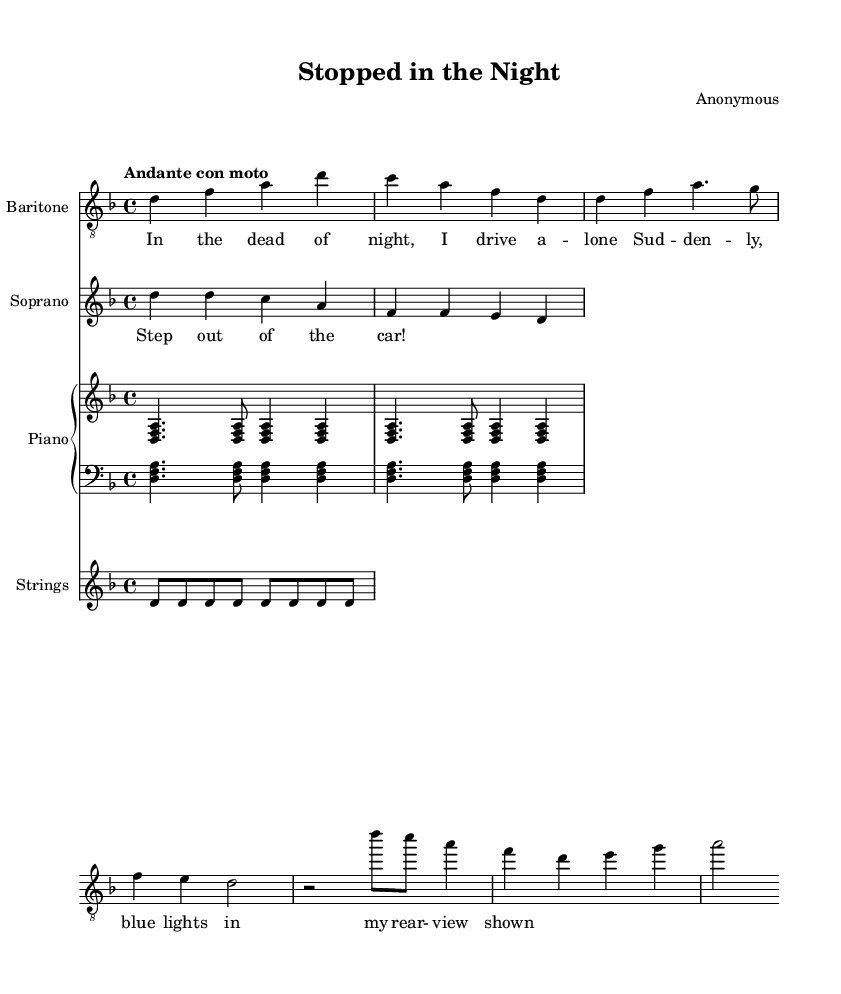What is the key signature of this music? The key signature in the piece is D minor, which has one flat (B flat). This is determined by identifying the key signature symbol at the beginning of the staff.
Answer: D minor What is the time signature of the music? The time signature is displayed at the beginning of the score and indicates the meter of the piece. In this case, it shows 4/4, meaning there are four beats per measure, and a quarter note gets one beat.
Answer: 4/4 What is the tempo marking for this operatic piece? The tempo marking is indicated above the staff. Here, it is labeled "Andante con moto," which specifies a moderate tempo with some movement.
Answer: Andante con moto Who is the vocalist for the taxi driver part? The vocal part for the taxi driver is labeled as "Baritone" in the score. This is shown in the staff heading at the beginning of the corresponding voice part.
Answer: Baritone How many measures does the taxi driver section contain in this excerpt? Counting the measures in the taxi driver part, we can see that there are six distinct measures, which are separated by bar lines.
Answer: Six What type of voice sings the police officer's part? The police officer's part is labeled as "Soprano" in the staff heading. This indicates that this part is written for higher vocal range, which is typical for a soprano singer.
Answer: Soprano What is the dynamic marking for the police officer's line? The dynamic marking for the police officer's line indicates how loudly or softly the music should be played. In this case, the exact dynamic markings can be assessed from the score, but in this excerpt, it is indicated implicitly by the context and intensity of the notes.
Answer: Not specified explicitly 